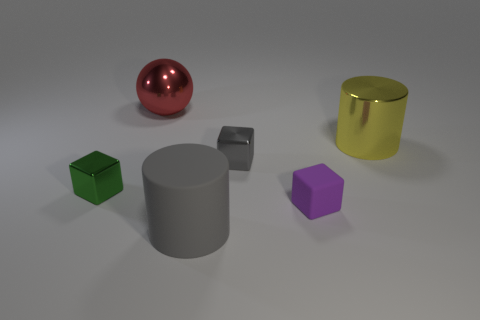The cylinder that is made of the same material as the small green thing is what color?
Your answer should be compact. Yellow. There is a shiny thing that is to the left of the red metal ball; is its size the same as the red ball on the left side of the purple block?
Provide a succinct answer. No. What shape is the tiny thing that is in front of the tiny gray metal block and on the right side of the ball?
Provide a short and direct response. Cube. Is there a yellow cylinder that has the same material as the tiny purple block?
Make the answer very short. No. There is a object that is the same color as the big rubber cylinder; what is its material?
Offer a very short reply. Metal. Do the cylinder behind the gray matte cylinder and the block left of the big red shiny sphere have the same material?
Your response must be concise. Yes. Are there more tiny purple matte cubes than blocks?
Provide a short and direct response. No. The shiny thing that is to the right of the small purple rubber block that is in front of the green shiny thing in front of the yellow cylinder is what color?
Provide a succinct answer. Yellow. There is a big metal object behind the metal cylinder; is it the same color as the block that is to the left of the metallic sphere?
Provide a short and direct response. No. What number of big shiny things are on the right side of the tiny metal object that is behind the green cube?
Your answer should be very brief. 1. 